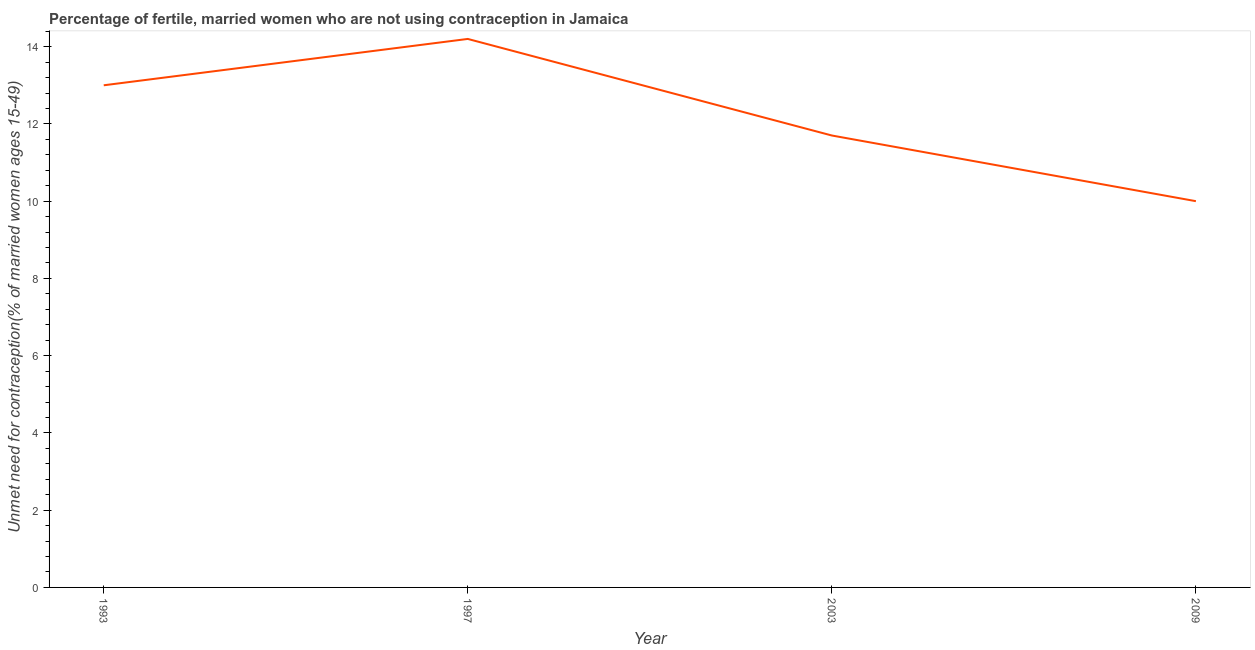In which year was the number of married women who are not using contraception maximum?
Make the answer very short. 1997. What is the sum of the number of married women who are not using contraception?
Your answer should be very brief. 48.9. What is the difference between the number of married women who are not using contraception in 1997 and 2009?
Provide a short and direct response. 4.2. What is the average number of married women who are not using contraception per year?
Provide a succinct answer. 12.22. What is the median number of married women who are not using contraception?
Provide a succinct answer. 12.35. What is the ratio of the number of married women who are not using contraception in 1993 to that in 2009?
Your answer should be very brief. 1.3. Is the difference between the number of married women who are not using contraception in 1993 and 2003 greater than the difference between any two years?
Provide a succinct answer. No. What is the difference between the highest and the second highest number of married women who are not using contraception?
Provide a succinct answer. 1.2. Is the sum of the number of married women who are not using contraception in 1993 and 2009 greater than the maximum number of married women who are not using contraception across all years?
Your answer should be very brief. Yes. What is the difference between the highest and the lowest number of married women who are not using contraception?
Ensure brevity in your answer.  4.2. How many lines are there?
Ensure brevity in your answer.  1. Does the graph contain any zero values?
Provide a short and direct response. No. What is the title of the graph?
Provide a short and direct response. Percentage of fertile, married women who are not using contraception in Jamaica. What is the label or title of the Y-axis?
Offer a terse response.  Unmet need for contraception(% of married women ages 15-49). What is the  Unmet need for contraception(% of married women ages 15-49) in 1993?
Keep it short and to the point. 13. What is the  Unmet need for contraception(% of married women ages 15-49) of 1997?
Offer a very short reply. 14.2. What is the difference between the  Unmet need for contraception(% of married women ages 15-49) in 1993 and 1997?
Your answer should be very brief. -1.2. What is the difference between the  Unmet need for contraception(% of married women ages 15-49) in 1993 and 2003?
Provide a short and direct response. 1.3. What is the difference between the  Unmet need for contraception(% of married women ages 15-49) in 1993 and 2009?
Ensure brevity in your answer.  3. What is the difference between the  Unmet need for contraception(% of married women ages 15-49) in 2003 and 2009?
Provide a short and direct response. 1.7. What is the ratio of the  Unmet need for contraception(% of married women ages 15-49) in 1993 to that in 1997?
Give a very brief answer. 0.92. What is the ratio of the  Unmet need for contraception(% of married women ages 15-49) in 1993 to that in 2003?
Your answer should be compact. 1.11. What is the ratio of the  Unmet need for contraception(% of married women ages 15-49) in 1993 to that in 2009?
Make the answer very short. 1.3. What is the ratio of the  Unmet need for contraception(% of married women ages 15-49) in 1997 to that in 2003?
Your answer should be very brief. 1.21. What is the ratio of the  Unmet need for contraception(% of married women ages 15-49) in 1997 to that in 2009?
Provide a succinct answer. 1.42. What is the ratio of the  Unmet need for contraception(% of married women ages 15-49) in 2003 to that in 2009?
Make the answer very short. 1.17. 